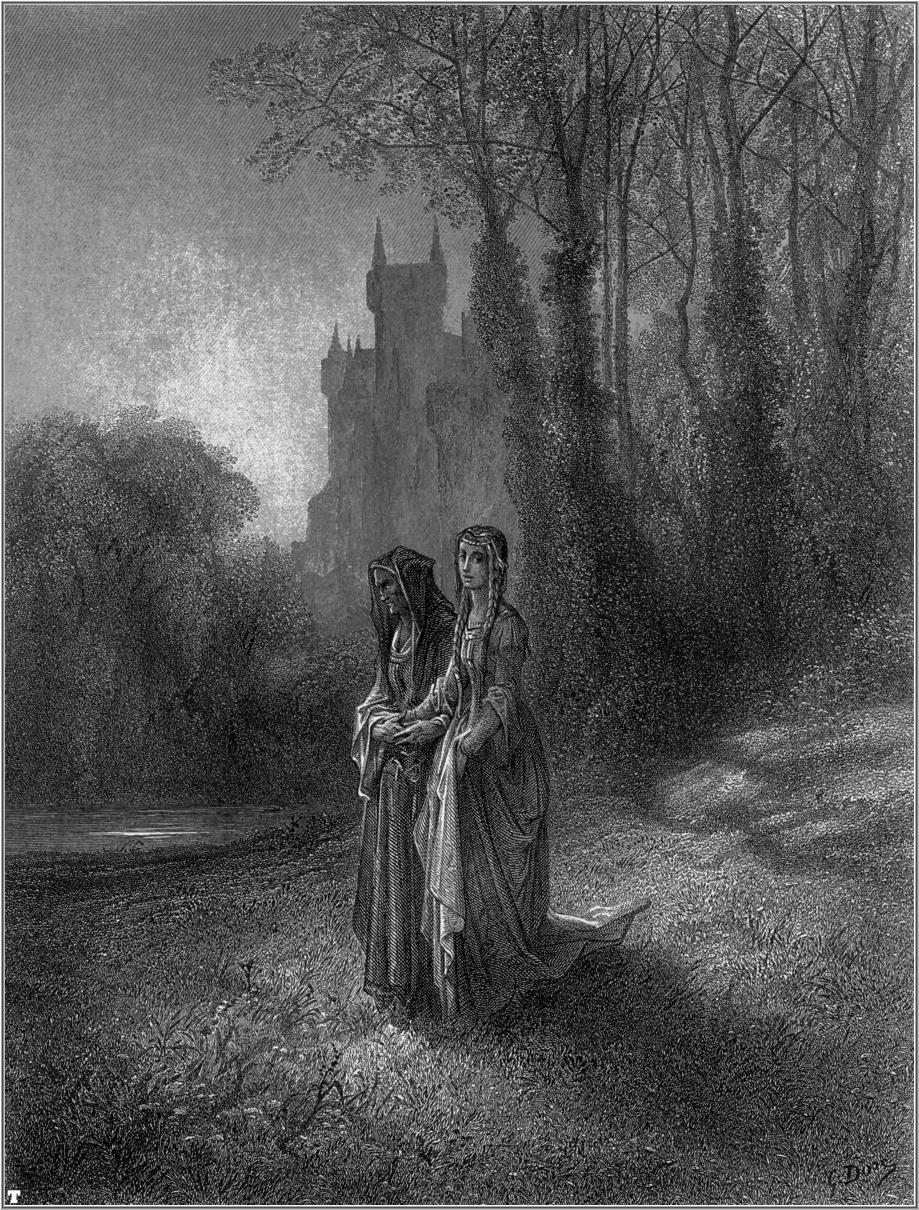Create a short poem inspired by the image. In whispers of the forest green,
Two figures drift in tranquil scene,
In flowing gowns with baskets light,
They wander through the fading light.
A castle stands in grayish hue,
A silent witness, ancient, true.
Beneath the lofty trees they roam,
In nature’s arms, they find their home. 